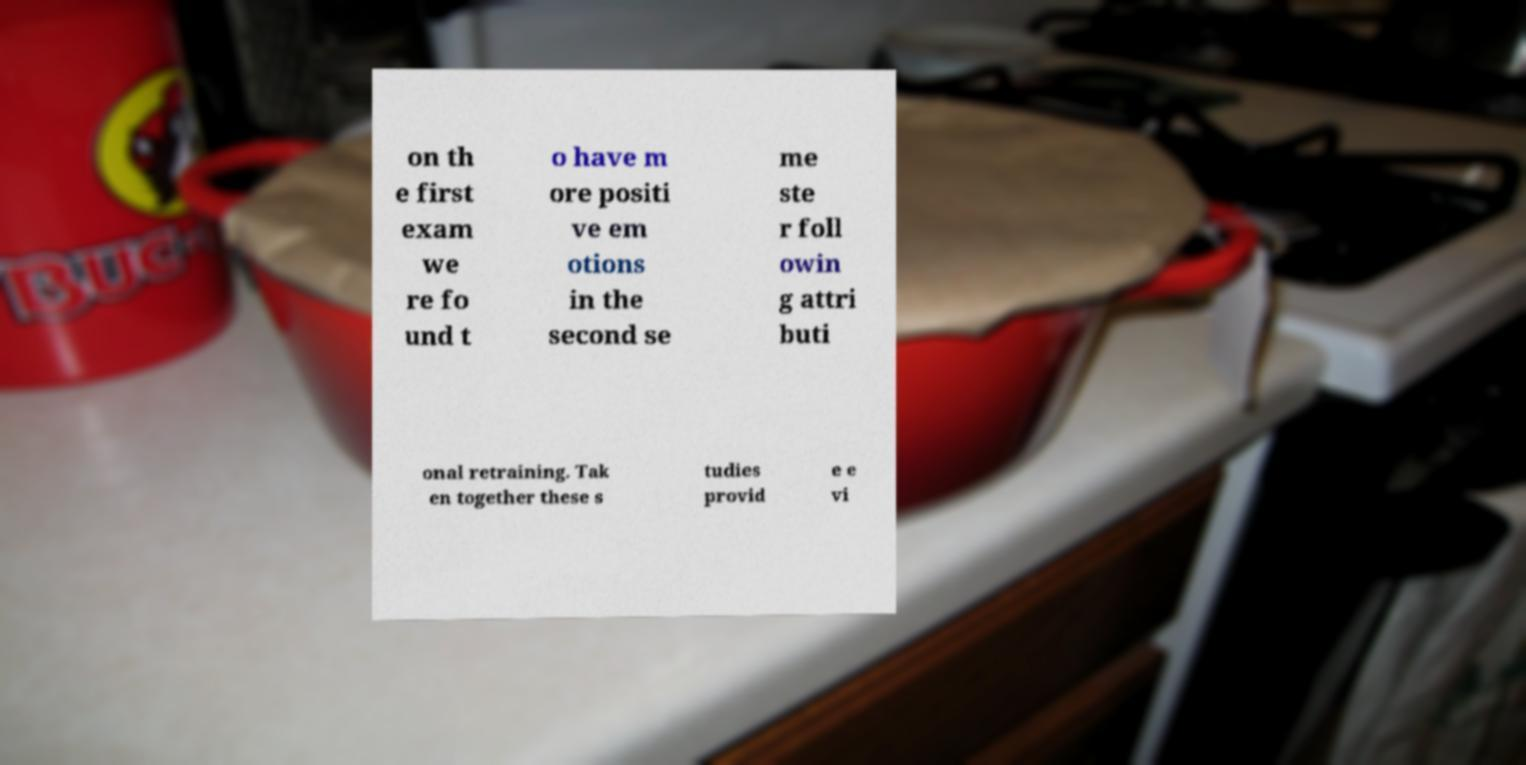Please identify and transcribe the text found in this image. on th e first exam we re fo und t o have m ore positi ve em otions in the second se me ste r foll owin g attri buti onal retraining. Tak en together these s tudies provid e e vi 